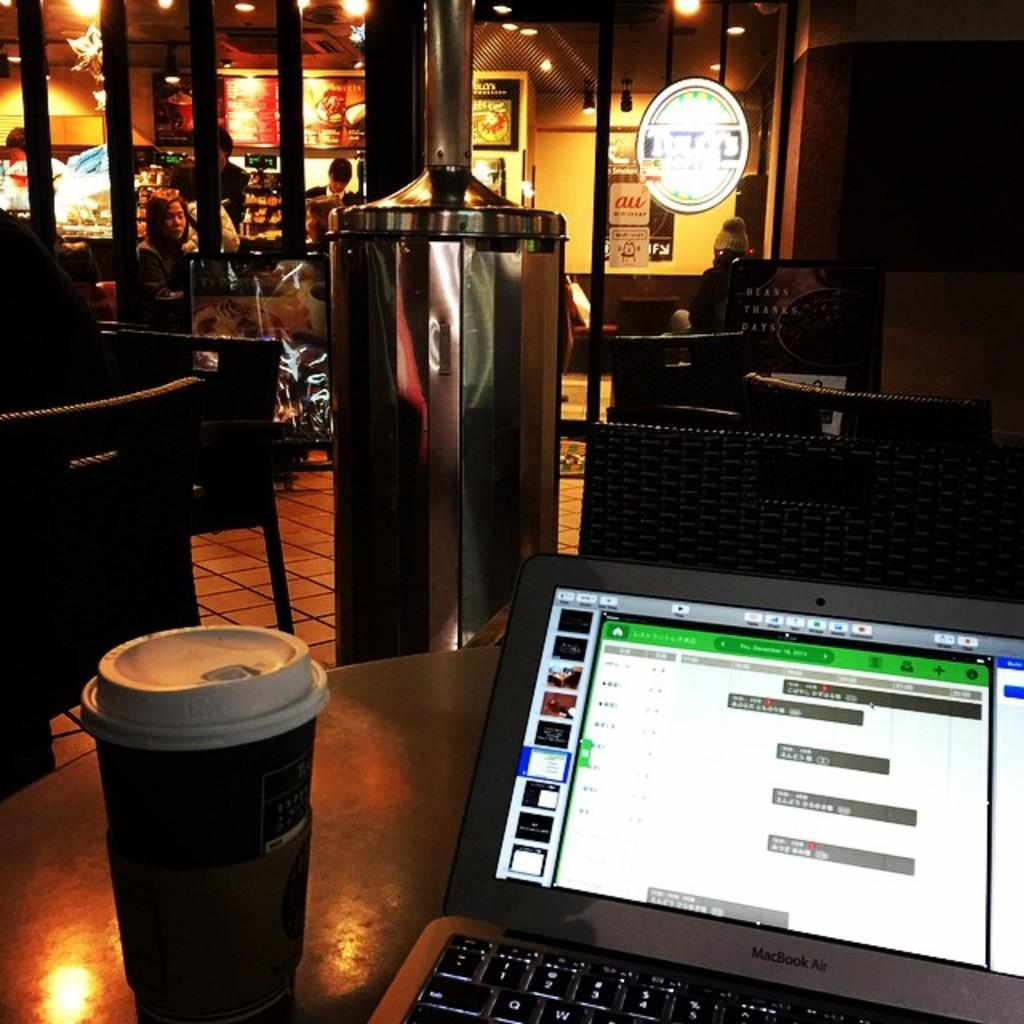<image>
Describe the image concisely. A sign on the window says au and has a smaller sign with a dog beneath it. 